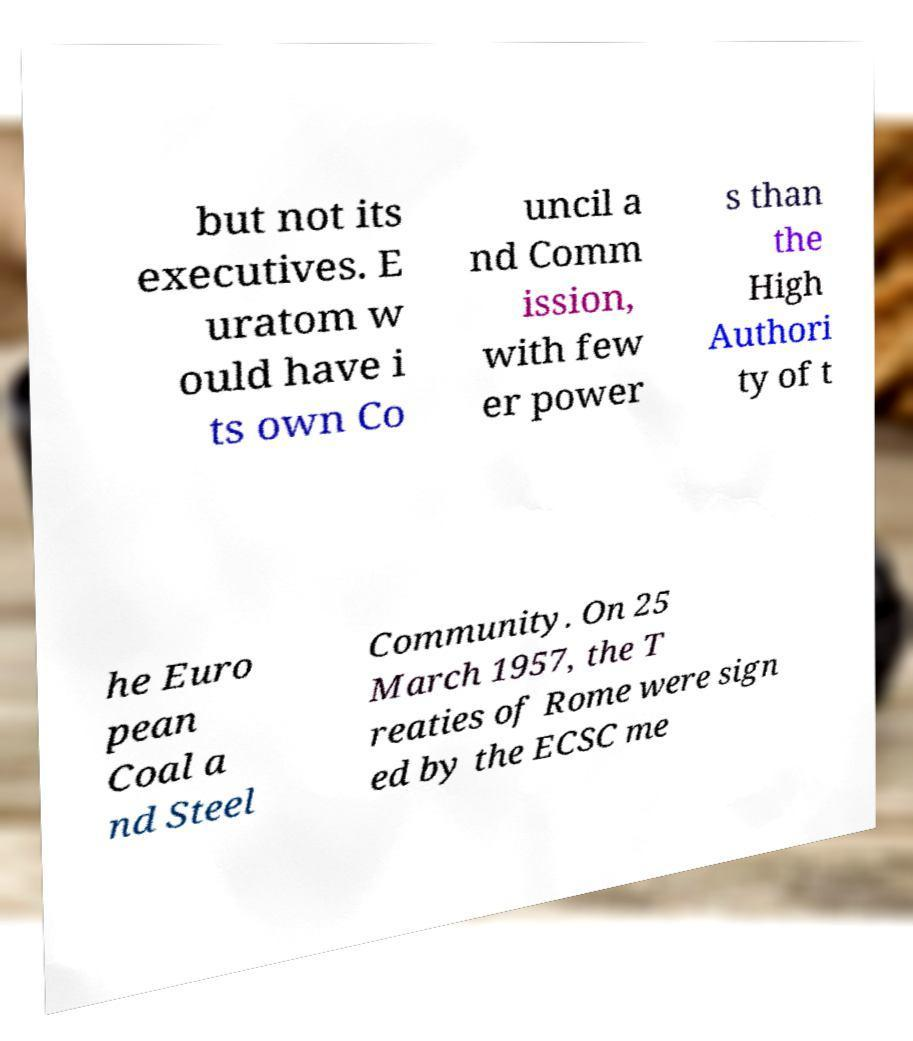I need the written content from this picture converted into text. Can you do that? but not its executives. E uratom w ould have i ts own Co uncil a nd Comm ission, with few er power s than the High Authori ty of t he Euro pean Coal a nd Steel Community. On 25 March 1957, the T reaties of Rome were sign ed by the ECSC me 